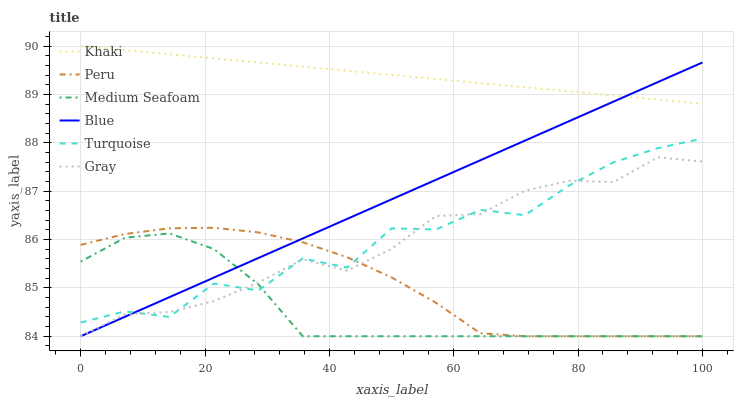Does Medium Seafoam have the minimum area under the curve?
Answer yes or no. Yes. Does Khaki have the maximum area under the curve?
Answer yes or no. Yes. Does Gray have the minimum area under the curve?
Answer yes or no. No. Does Gray have the maximum area under the curve?
Answer yes or no. No. Is Blue the smoothest?
Answer yes or no. Yes. Is Turquoise the roughest?
Answer yes or no. Yes. Is Gray the smoothest?
Answer yes or no. No. Is Gray the roughest?
Answer yes or no. No. Does Blue have the lowest value?
Answer yes or no. Yes. Does Turquoise have the lowest value?
Answer yes or no. No. Does Khaki have the highest value?
Answer yes or no. Yes. Does Gray have the highest value?
Answer yes or no. No. Is Turquoise less than Khaki?
Answer yes or no. Yes. Is Khaki greater than Peru?
Answer yes or no. Yes. Does Turquoise intersect Peru?
Answer yes or no. Yes. Is Turquoise less than Peru?
Answer yes or no. No. Is Turquoise greater than Peru?
Answer yes or no. No. Does Turquoise intersect Khaki?
Answer yes or no. No. 